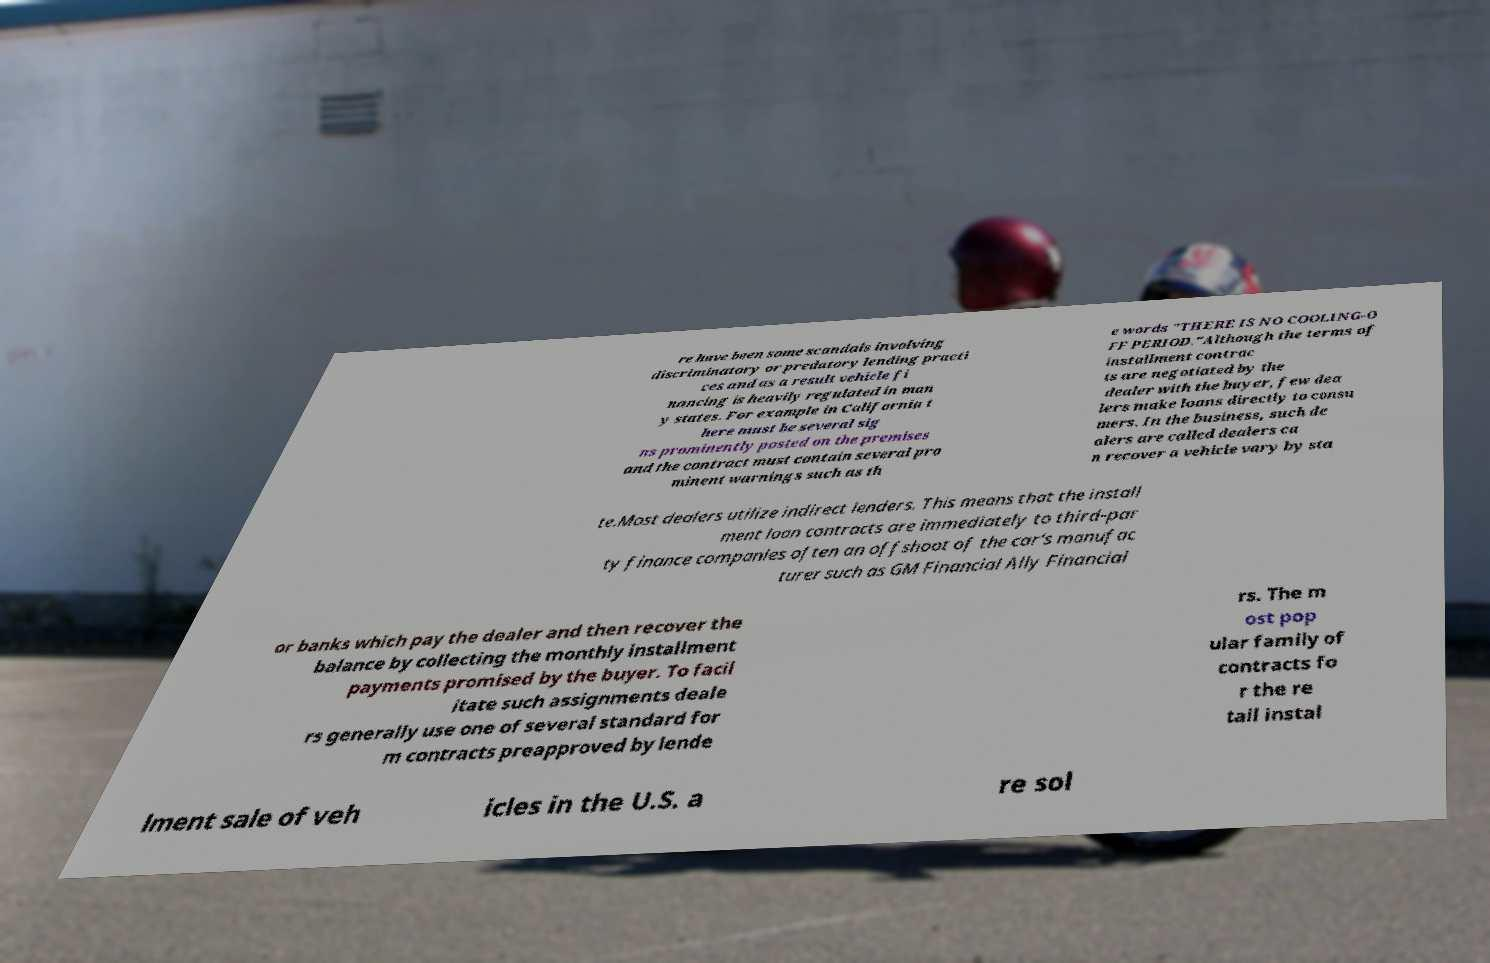Could you assist in decoding the text presented in this image and type it out clearly? re have been some scandals involving discriminatory or predatory lending practi ces and as a result vehicle fi nancing is heavily regulated in man y states. For example in California t here must be several sig ns prominently posted on the premises and the contract must contain several pro minent warnings such as th e words "THERE IS NO COOLING-O FF PERIOD."Although the terms of installment contrac ts are negotiated by the dealer with the buyer, few dea lers make loans directly to consu mers. In the business, such de alers are called dealers ca n recover a vehicle vary by sta te.Most dealers utilize indirect lenders. This means that the install ment loan contracts are immediately to third-par ty finance companies often an offshoot of the car's manufac turer such as GM Financial Ally Financial or banks which pay the dealer and then recover the balance by collecting the monthly installment payments promised by the buyer. To facil itate such assignments deale rs generally use one of several standard for m contracts preapproved by lende rs. The m ost pop ular family of contracts fo r the re tail instal lment sale of veh icles in the U.S. a re sol 